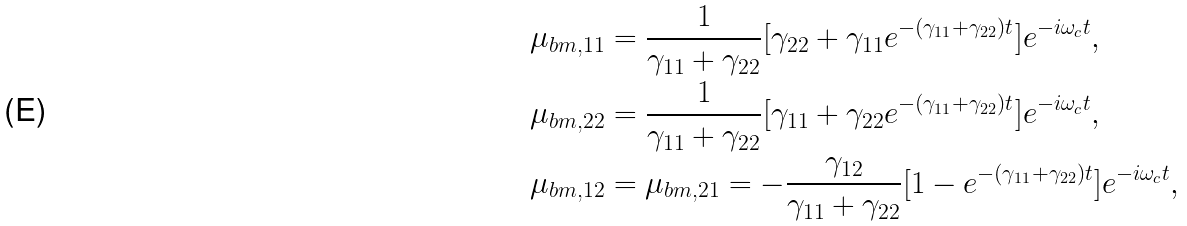Convert formula to latex. <formula><loc_0><loc_0><loc_500><loc_500>\mu _ { b m , 1 1 } & = \frac { 1 } { \gamma _ { 1 1 } + \gamma _ { 2 2 } } [ \gamma _ { 2 2 } + \gamma _ { 1 1 } e ^ { - ( \gamma _ { 1 1 } + \gamma _ { 2 2 } ) t } ] e ^ { - i \omega _ { c } t } , \\ \mu _ { b m , 2 2 } & = \frac { 1 } { \gamma _ { 1 1 } + \gamma _ { 2 2 } } [ \gamma _ { 1 1 } + \gamma _ { 2 2 } e ^ { - ( \gamma _ { 1 1 } + \gamma _ { 2 2 } ) t } ] e ^ { - i \omega _ { c } t } , \\ \mu _ { b m , 1 2 } & = \mu _ { b m , 2 1 } = - \frac { \gamma _ { 1 2 } } { \gamma _ { 1 1 } + \gamma _ { 2 2 } } [ 1 - e ^ { - ( \gamma _ { 1 1 } + \gamma _ { 2 2 } ) t } ] e ^ { - i \omega _ { c } t } ,</formula> 